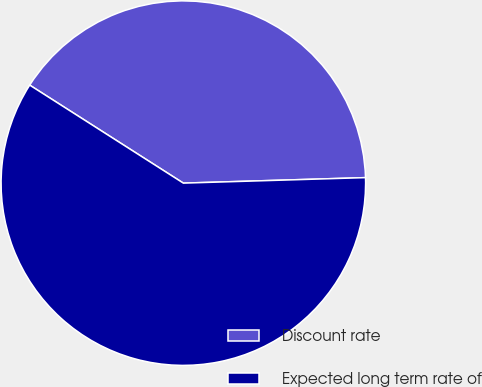Convert chart. <chart><loc_0><loc_0><loc_500><loc_500><pie_chart><fcel>Discount rate<fcel>Expected long term rate of<nl><fcel>40.48%<fcel>59.52%<nl></chart> 